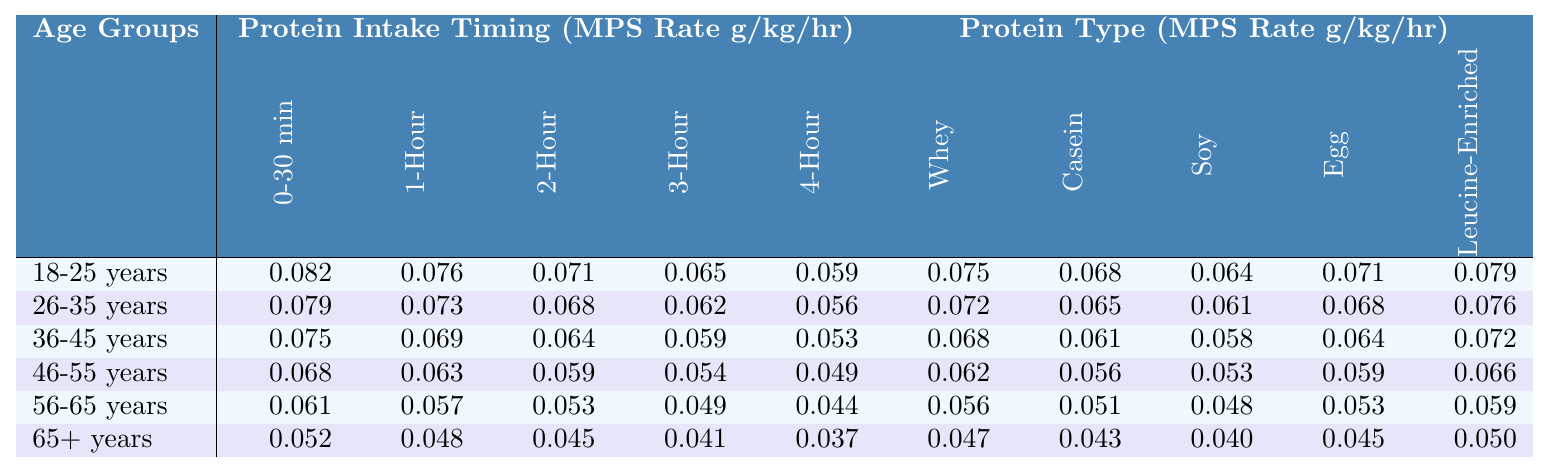What is the highest Whey Protein MPS Rate among the age groups? The Whey Protein MPS Rates for each age group is as follows: 0.075 (18-25), 0.072 (26-35), 0.068 (36-45), 0.062 (46-55), 0.056 (56-65), and 0.047 (65+). The highest value is 0.075 for the age group 18-25.
Answer: 0.075 (18-25 years) Which age group has the lowest 4-Hour Post-Exercise Protein Intake? The 4-Hour Post-Exercise Protein Intake values for each age group are: 0.059 (18-25), 0.056 (26-35), 0.053 (36-45), 0.049 (46-55), 0.044 (56-65), and 0.037 (65+). The lowest value is 0.037 for the age group 65+.
Answer: 0.037 (65+ years) What is the difference in Immediate Post-Exercise Protein Intake between the youngest and the oldest age groups? The Immediate Post-Exercise Protein Intake for the youngest (18-25 years) is 0.082, while for the oldest (65+ years) it is 0.052. The difference is calculated as 0.082 - 0.052 = 0.030.
Answer: 0.030 Is the Leucine-Enriched Protein MPS Rate higher in the 36-45 age group than in the 56-65 age group? The Leucine-Enriched Protein MPS Rates are 0.072 for 36-45 years and 0.059 for 56-65 years. Since 0.072 is greater than 0.059, the statement is true.
Answer: Yes What is the average Soy Protein MPS Rate across all age groups? The Soy Protein MPS Rates are: 0.064 (18-25), 0.061 (26-35), 0.058 (36-45), 0.053 (46-55), 0.048 (56-65), and 0.040 (65+). The sum of these values is 0.064 + 0.061 + 0.058 + 0.053 + 0.048 + 0.040 = 0.324. Dividing by the number of age groups (6), the average is 0.324 / 6 = 0.054.
Answer: 0.054 Which protein type has the highest synthesis rate for the age group 26-35 years? The MPS Rates for 26-35 years are: Whey 0.072, Casein 0.065, Soy 0.061, Egg 0.068, and Leucine-Enriched 0.076. The highest among these is 0.072 for Whey Protein.
Answer: Whey Protein (0.072) What is the trend in MPS rates for Immediate Post-Exercise Protein Intake as age increases? From the table, the values for Immediate Post-Exercise Protein Intake decrease as age groups move from younger (0.082) to older (0.052), indicating a downward trend.
Answer: Decreasing trend What is the overall decrease in the Egg Protein MPS Rate from the youngest to the oldest age group? The Egg Protein MPS Rates for the age groups are: 0.071 (18-25) and 0.045 (65+). The decrease is calculated as 0.071 - 0.045 = 0.026.
Answer: 0.026 Is the difference between the 0-30 min and 3-Hour Post-Exercise Protein Intake higher for the age group 46-55 compared to 56-65? For age group 46-55, the difference is 0.068 - 0.054 = 0.014. For age group 56-65, the difference is 0.061 - 0.049 = 0.012. Since 0.014 is greater than 0.012, the statement is true.
Answer: Yes What is the median value of the Casein Protein MPS Rates across the age groups? The Casein Protein MPS Rates in ascending order are: 0.043, 0.051, 0.056, 0.061, 0.065, and 0.068. The median, which is the average of the 3rd and 4th values, (0.056 + 0.061)/2 = 0.0585.
Answer: 0.0585 